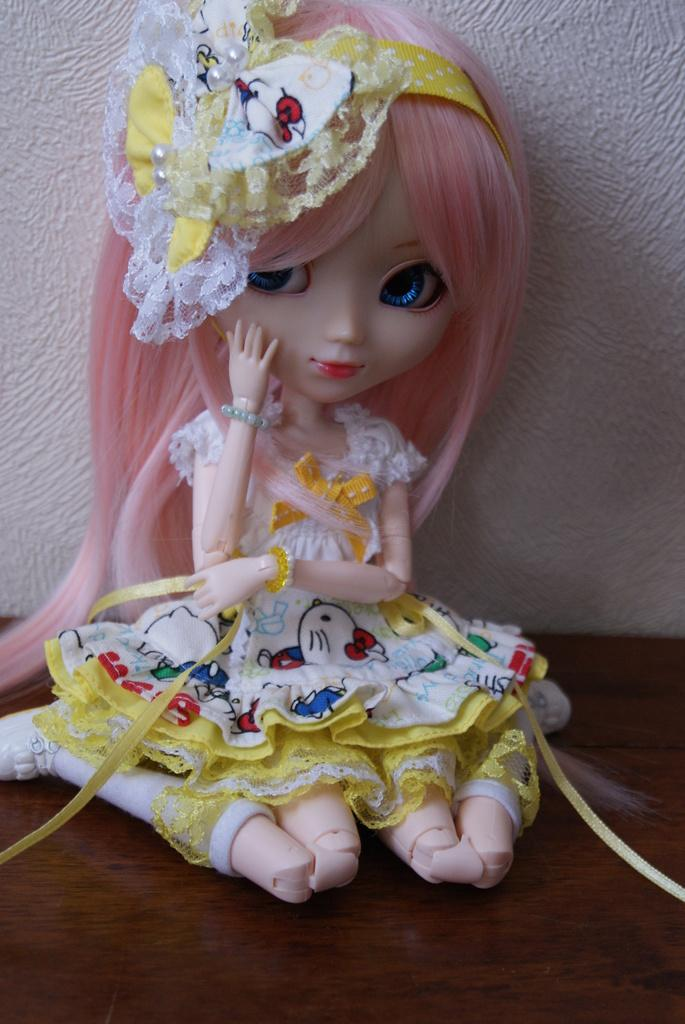What is the main subject of the image? There is a doll in the image. Where is the doll located in the image? The doll is in the center of the image. What is the doll wearing? The doll is wearing a yellow and white color dress and a yellow color hair band. How far away is the rainstorm from the doll in the image? There is no rainstorm present in the image, so it cannot be determined how far away it is from the doll. 